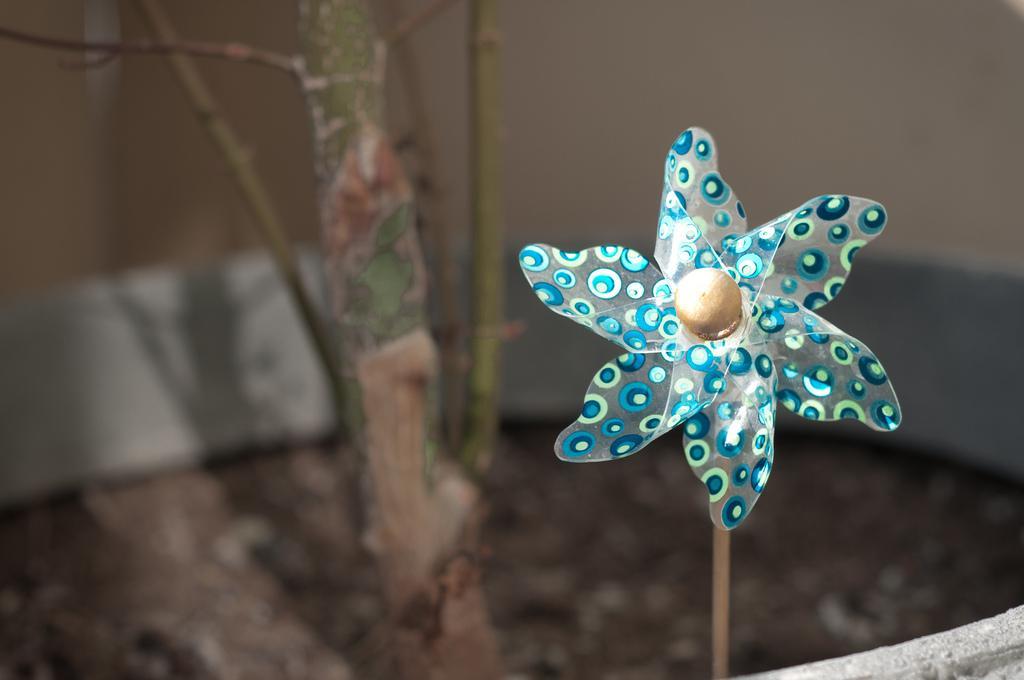Could you give a brief overview of what you see in this image? We can able to see a craft. It has a wood stick. 